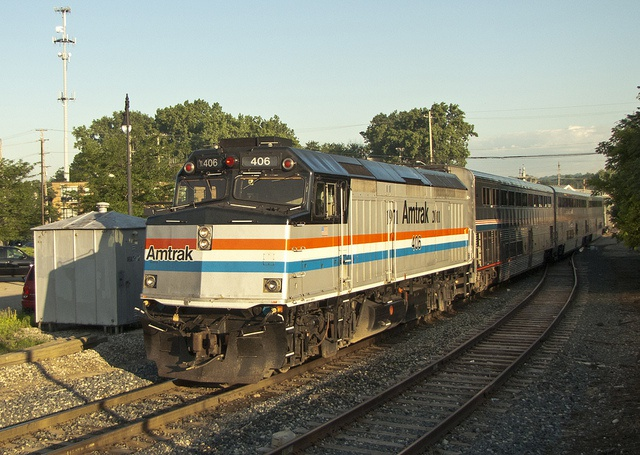Describe the objects in this image and their specific colors. I can see train in lightblue, black, gray, and tan tones, car in lightblue, black, and gray tones, and car in lightblue, black, maroon, gray, and beige tones in this image. 